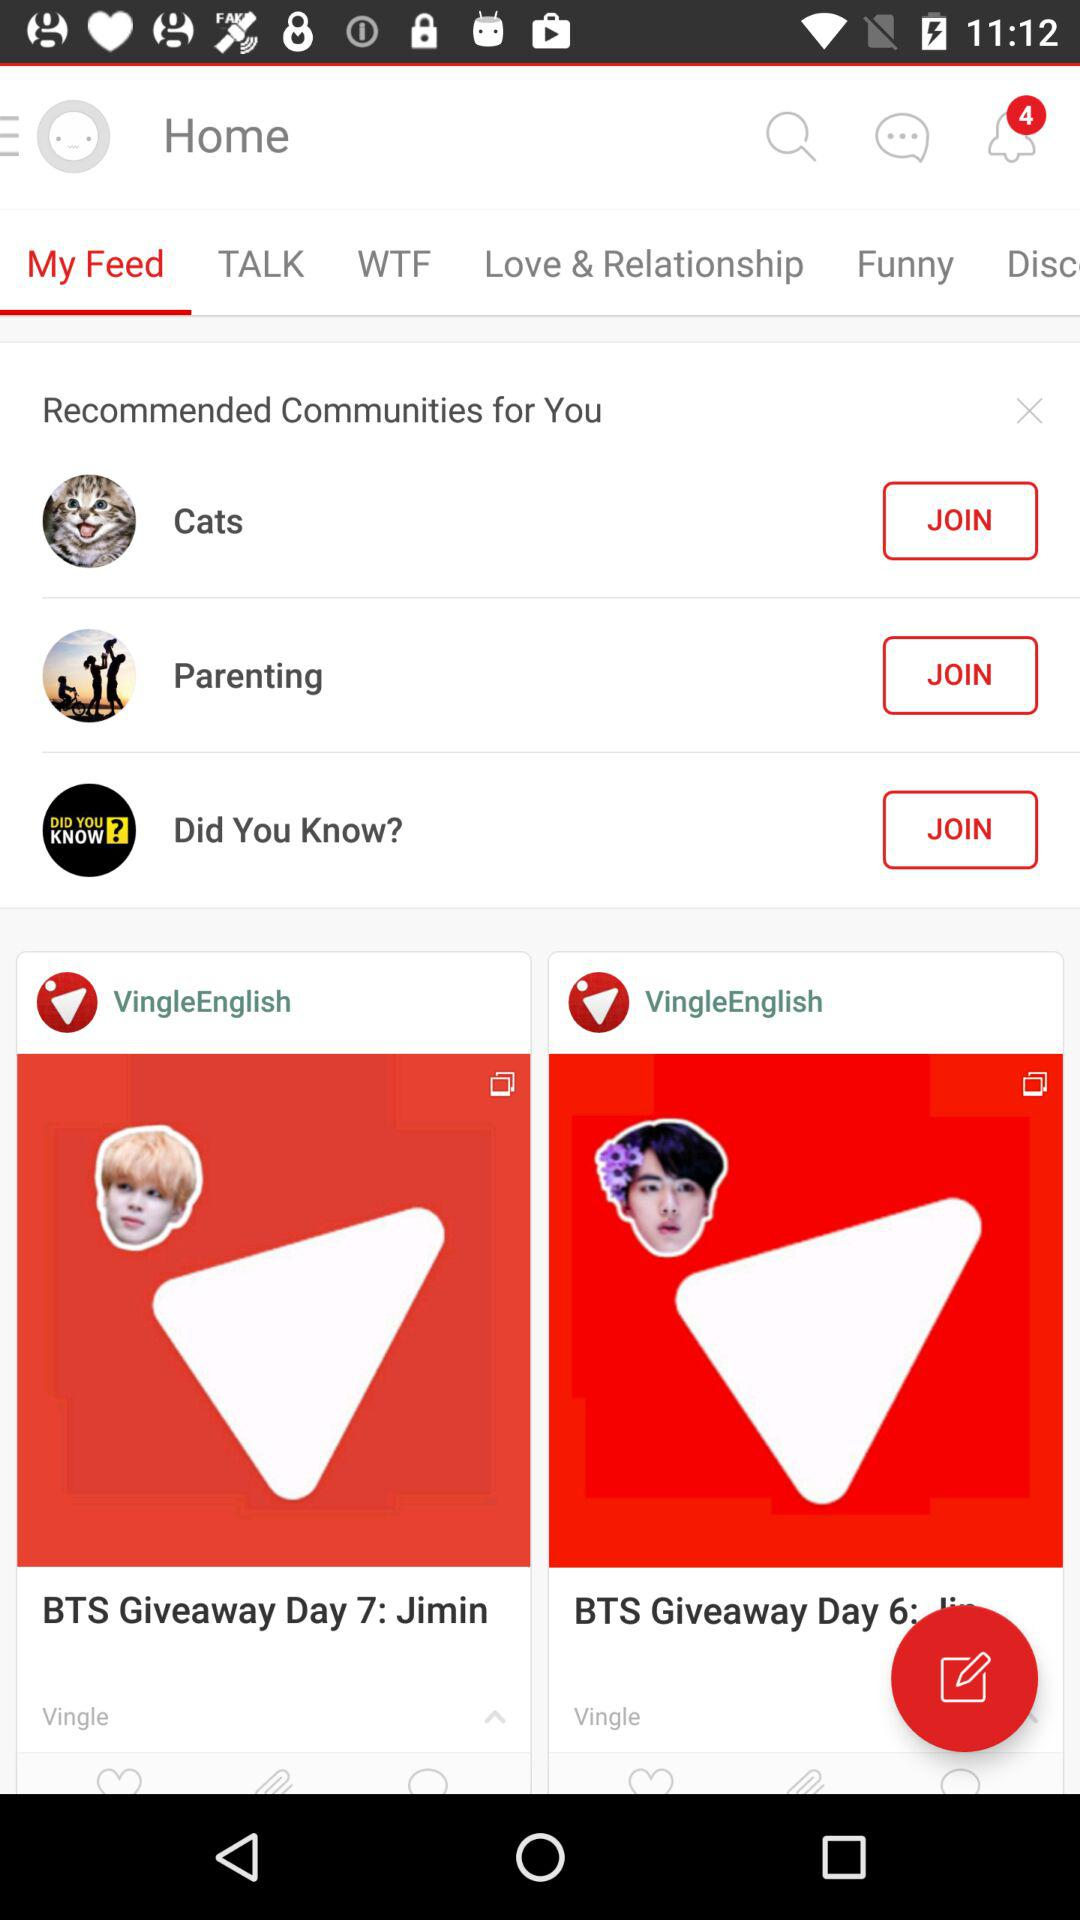How many notifications in total are shown? There are 4 notifications in total. 